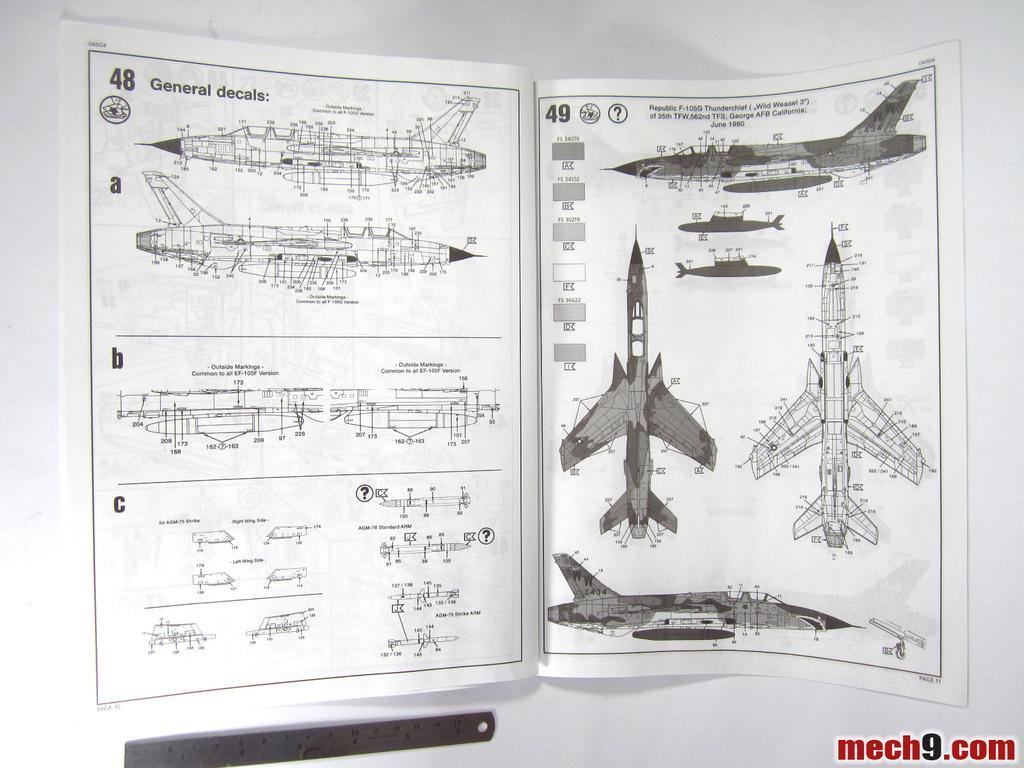Could you give a brief overview of what you see in this image? In this picture we can see an open book on a white surface. There is the sketch of an aircraft's on the left side. We can see a few aircrafts on the right side. There is a text visible in the bottom right. 